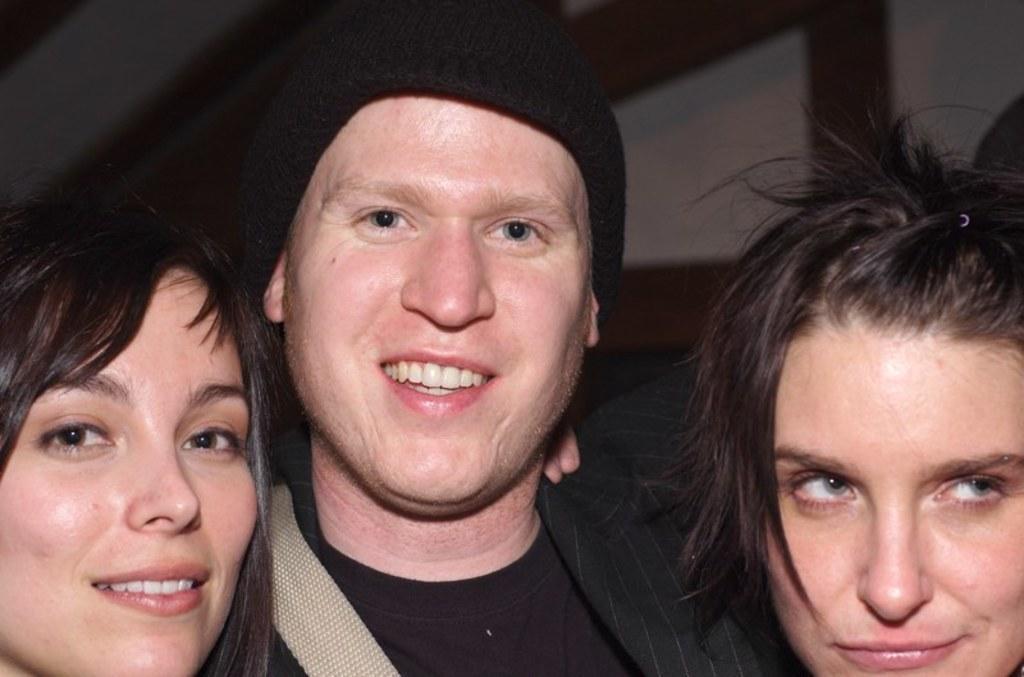In one or two sentences, can you explain what this image depicts? In this image there are two people wearing a smile on their faces. Beside them there is another person. 